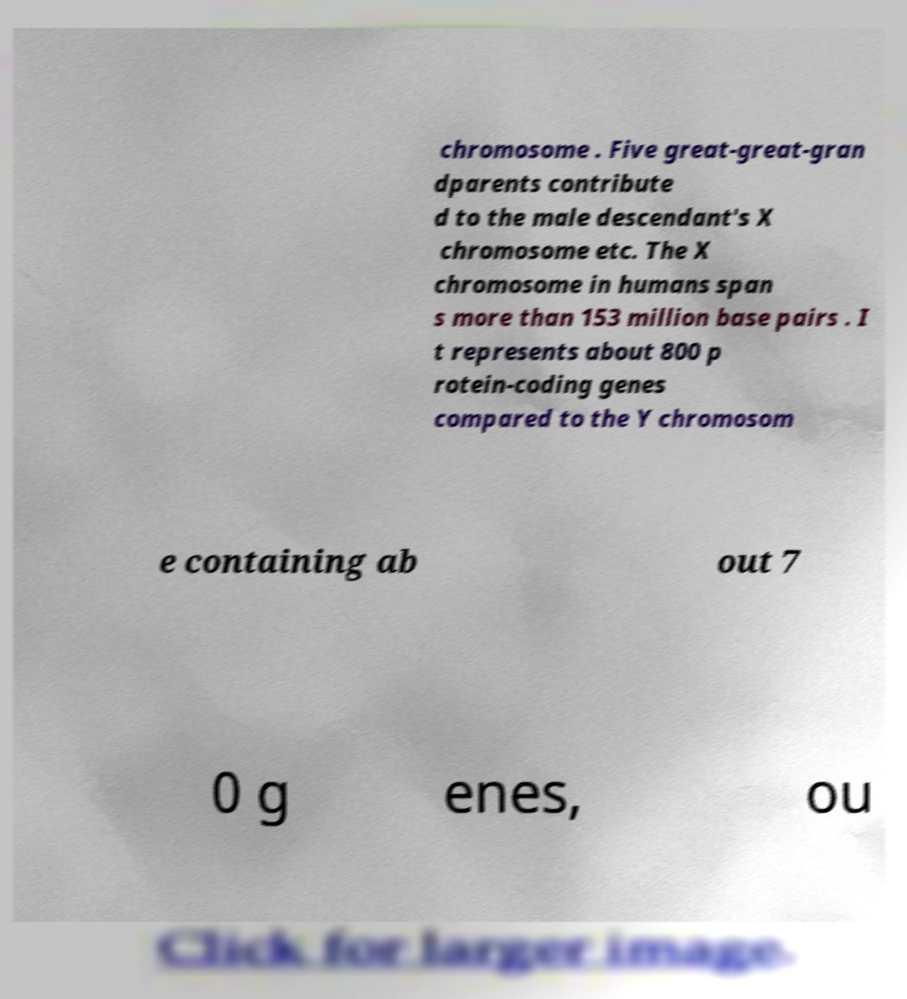What messages or text are displayed in this image? I need them in a readable, typed format. chromosome . Five great-great-gran dparents contribute d to the male descendant's X chromosome etc. The X chromosome in humans span s more than 153 million base pairs . I t represents about 800 p rotein-coding genes compared to the Y chromosom e containing ab out 7 0 g enes, ou 